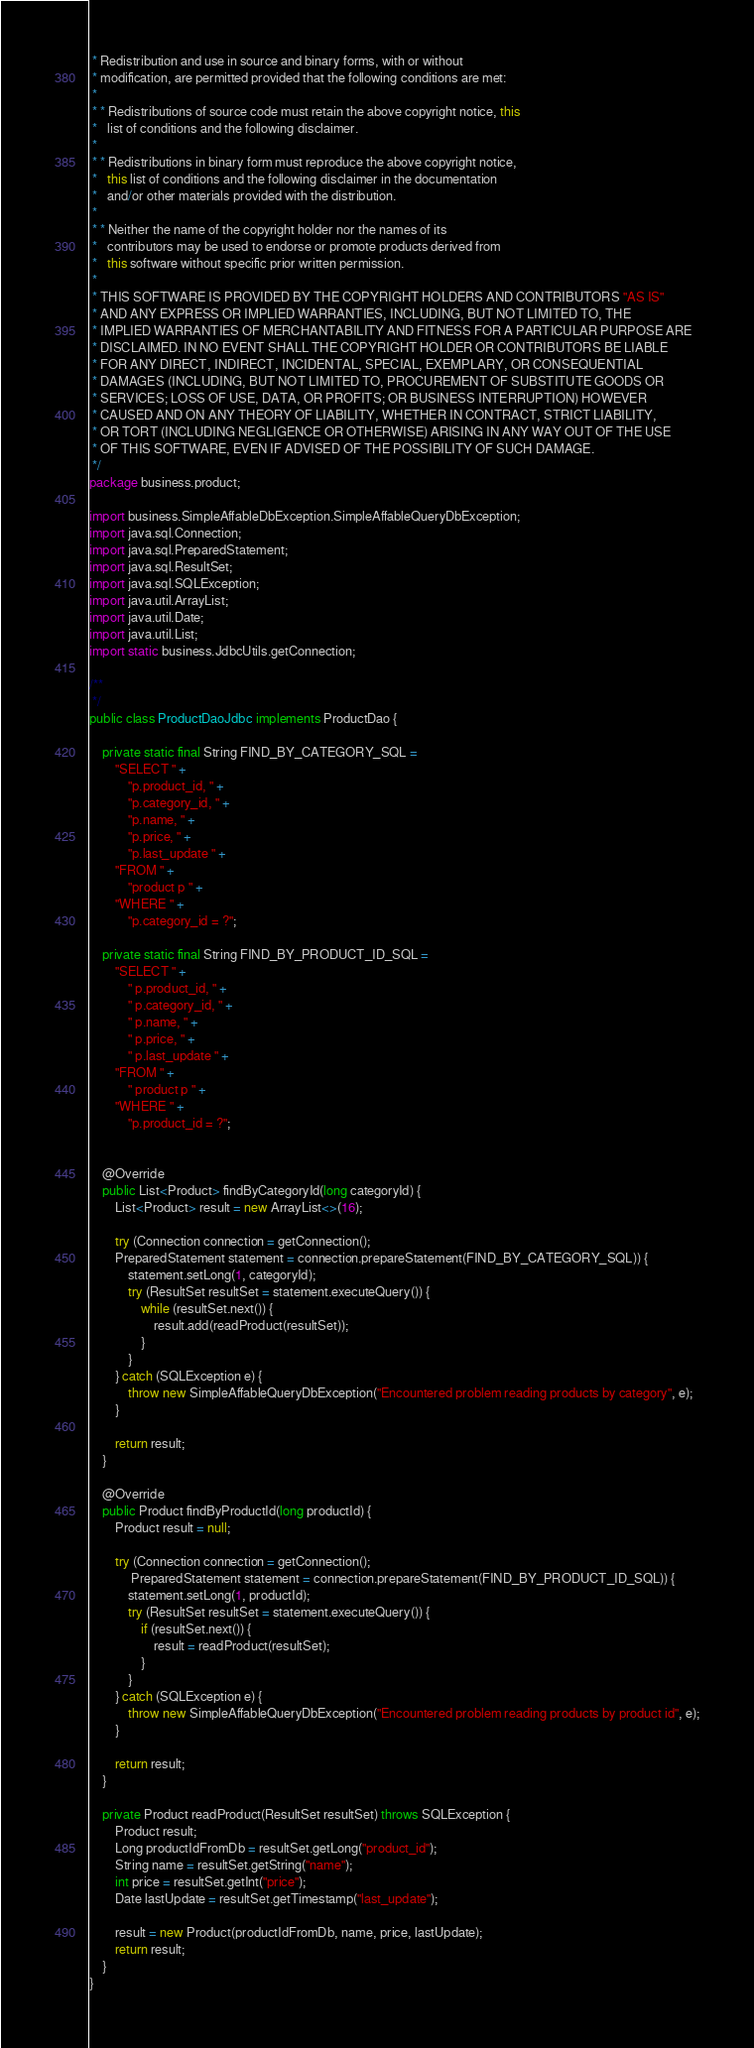<code> <loc_0><loc_0><loc_500><loc_500><_Java_> * Redistribution and use in source and binary forms, with or without
 * modification, are permitted provided that the following conditions are met:
 *
 * * Redistributions of source code must retain the above copyright notice, this
 *   list of conditions and the following disclaimer.
 *
 * * Redistributions in binary form must reproduce the above copyright notice,
 *   this list of conditions and the following disclaimer in the documentation
 *   and/or other materials provided with the distribution.
 *
 * * Neither the name of the copyright holder nor the names of its
 *   contributors may be used to endorse or promote products derived from
 *   this software without specific prior written permission.
 *
 * THIS SOFTWARE IS PROVIDED BY THE COPYRIGHT HOLDERS AND CONTRIBUTORS "AS IS"
 * AND ANY EXPRESS OR IMPLIED WARRANTIES, INCLUDING, BUT NOT LIMITED TO, THE
 * IMPLIED WARRANTIES OF MERCHANTABILITY AND FITNESS FOR A PARTICULAR PURPOSE ARE
 * DISCLAIMED. IN NO EVENT SHALL THE COPYRIGHT HOLDER OR CONTRIBUTORS BE LIABLE
 * FOR ANY DIRECT, INDIRECT, INCIDENTAL, SPECIAL, EXEMPLARY, OR CONSEQUENTIAL
 * DAMAGES (INCLUDING, BUT NOT LIMITED TO, PROCUREMENT OF SUBSTITUTE GOODS OR
 * SERVICES; LOSS OF USE, DATA, OR PROFITS; OR BUSINESS INTERRUPTION) HOWEVER
 * CAUSED AND ON ANY THEORY OF LIABILITY, WHETHER IN CONTRACT, STRICT LIABILITY,
 * OR TORT (INCLUDING NEGLIGENCE OR OTHERWISE) ARISING IN ANY WAY OUT OF THE USE
 * OF THIS SOFTWARE, EVEN IF ADVISED OF THE POSSIBILITY OF SUCH DAMAGE.
 */
package business.product;

import business.SimpleAffableDbException.SimpleAffableQueryDbException;
import java.sql.Connection;
import java.sql.PreparedStatement;
import java.sql.ResultSet;
import java.sql.SQLException;
import java.util.ArrayList;
import java.util.Date;
import java.util.List;
import static business.JdbcUtils.getConnection;

/**
 */
public class ProductDaoJdbc implements ProductDao {

    private static final String FIND_BY_CATEGORY_SQL =
        "SELECT " +
            "p.product_id, " +
            "p.category_id, " +
            "p.name, " +
            "p.price, " +
            "p.last_update " +
        "FROM " +
            "product p " +
        "WHERE " +
            "p.category_id = ?";

    private static final String FIND_BY_PRODUCT_ID_SQL =
        "SELECT " +
            " p.product_id, " +
            " p.category_id, " +
            " p.name, " +
            " p.price, " +
            " p.last_update " +
        "FROM " +
            " product p " +
        "WHERE " +
            "p.product_id = ?";


    @Override
    public List<Product> findByCategoryId(long categoryId) {
        List<Product> result = new ArrayList<>(16);

        try (Connection connection = getConnection();
        PreparedStatement statement = connection.prepareStatement(FIND_BY_CATEGORY_SQL)) {
            statement.setLong(1, categoryId);
            try (ResultSet resultSet = statement.executeQuery()) {
                while (resultSet.next()) {
                    result.add(readProduct(resultSet));
                }
            }
        } catch (SQLException e) {
            throw new SimpleAffableQueryDbException("Encountered problem reading products by category", e);
        }

        return result;
    }

    @Override
    public Product findByProductId(long productId) {
        Product result = null;

        try (Connection connection = getConnection();
             PreparedStatement statement = connection.prepareStatement(FIND_BY_PRODUCT_ID_SQL)) {
            statement.setLong(1, productId);
            try (ResultSet resultSet = statement.executeQuery()) {
                if (resultSet.next()) {
                    result = readProduct(resultSet);
                }
            }
        } catch (SQLException e) {
            throw new SimpleAffableQueryDbException("Encountered problem reading products by product id", e);
        }

        return result;
    }

    private Product readProduct(ResultSet resultSet) throws SQLException {
        Product result;
        Long productIdFromDb = resultSet.getLong("product_id");
        String name = resultSet.getString("name");
        int price = resultSet.getInt("price");
        Date lastUpdate = resultSet.getTimestamp("last_update");

        result = new Product(productIdFromDb, name, price, lastUpdate);
        return result;
    }
}
</code> 